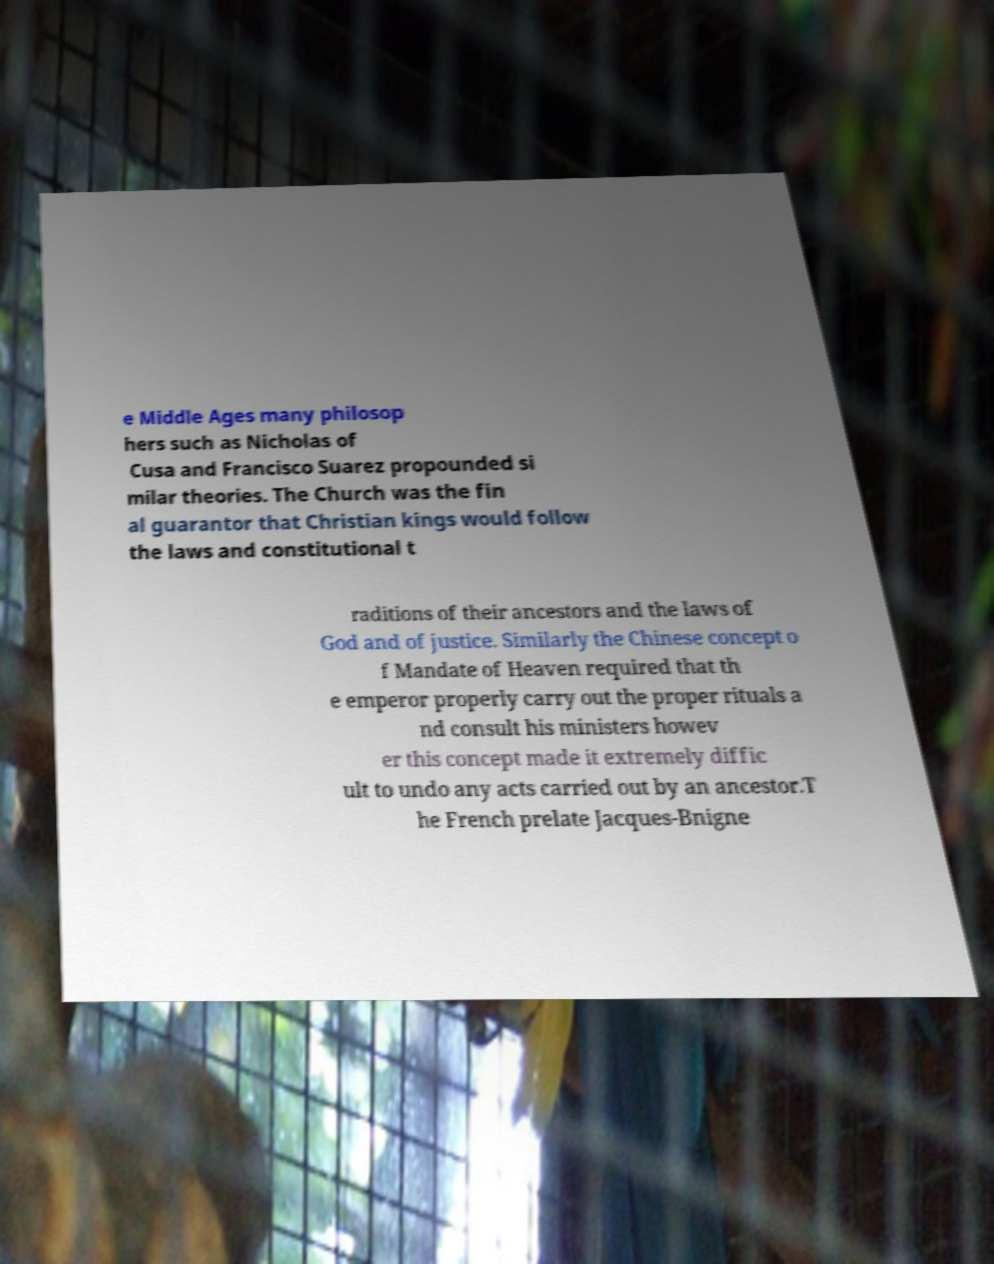I need the written content from this picture converted into text. Can you do that? e Middle Ages many philosop hers such as Nicholas of Cusa and Francisco Suarez propounded si milar theories. The Church was the fin al guarantor that Christian kings would follow the laws and constitutional t raditions of their ancestors and the laws of God and of justice. Similarly the Chinese concept o f Mandate of Heaven required that th e emperor properly carry out the proper rituals a nd consult his ministers howev er this concept made it extremely diffic ult to undo any acts carried out by an ancestor.T he French prelate Jacques-Bnigne 